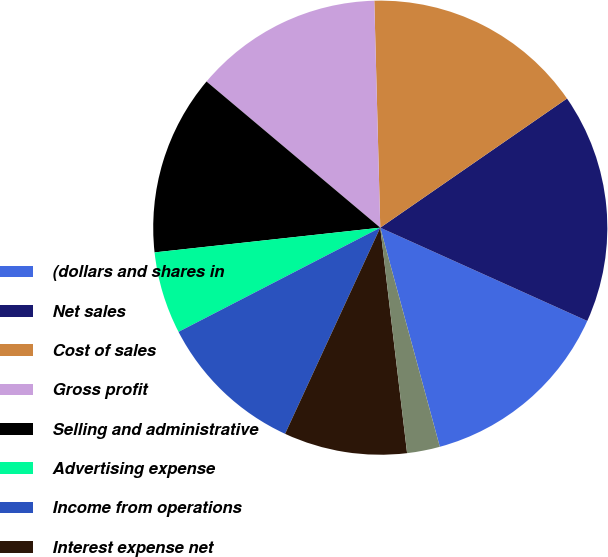Convert chart to OTSL. <chart><loc_0><loc_0><loc_500><loc_500><pie_chart><fcel>(dollars and shares in<fcel>Net sales<fcel>Cost of sales<fcel>Gross profit<fcel>Selling and administrative<fcel>Advertising expense<fcel>Income from operations<fcel>Interest expense net<fcel>Net (loss) gain on<fcel>Other income net<nl><fcel>14.04%<fcel>16.37%<fcel>15.79%<fcel>13.45%<fcel>12.87%<fcel>5.85%<fcel>10.53%<fcel>8.77%<fcel>2.34%<fcel>0.0%<nl></chart> 